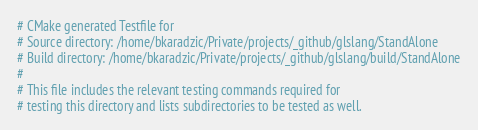<code> <loc_0><loc_0><loc_500><loc_500><_CMake_># CMake generated Testfile for 
# Source directory: /home/bkaradzic/Private/projects/_github/glslang/StandAlone
# Build directory: /home/bkaradzic/Private/projects/_github/glslang/build/StandAlone
# 
# This file includes the relevant testing commands required for 
# testing this directory and lists subdirectories to be tested as well.
</code> 